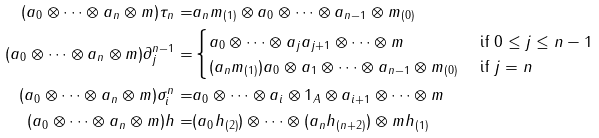<formula> <loc_0><loc_0><loc_500><loc_500>( a _ { 0 } \otimes \cdots \otimes a _ { n } \otimes m ) \tau _ { n } = & a _ { n } m _ { ( 1 ) } \otimes a _ { 0 } \otimes \cdots \otimes a _ { n - 1 } \otimes m _ { ( 0 ) } \\ ( a _ { 0 } \otimes \cdots \otimes a _ { n } \otimes m ) \partial ^ { n - 1 } _ { j } = & \begin{cases} a _ { 0 } \otimes \cdots \otimes a _ { j } a _ { j + 1 } \otimes \cdots \otimes m & \text { if } 0 \leq j \leq n - 1 \\ ( a _ { n } m _ { ( 1 ) } ) a _ { 0 } \otimes a _ { 1 } \otimes \cdots \otimes a _ { n - 1 } \otimes m _ { ( 0 ) } & \text { if } j = n \end{cases} \\ ( a _ { 0 } \otimes \cdots \otimes a _ { n } \otimes m ) \sigma ^ { n } _ { i } = & a _ { 0 } \otimes \cdots \otimes a _ { i } \otimes 1 _ { A } \otimes a _ { i + 1 } \otimes \cdots \otimes m \\ ( a _ { 0 } \otimes \cdots \otimes a _ { n } \otimes m ) h = & ( a _ { 0 } h _ { ( 2 ) } ) \otimes \cdots \otimes ( a _ { n } h _ { ( n + 2 ) } ) \otimes m h _ { ( 1 ) }</formula> 